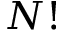<formula> <loc_0><loc_0><loc_500><loc_500>N !</formula> 